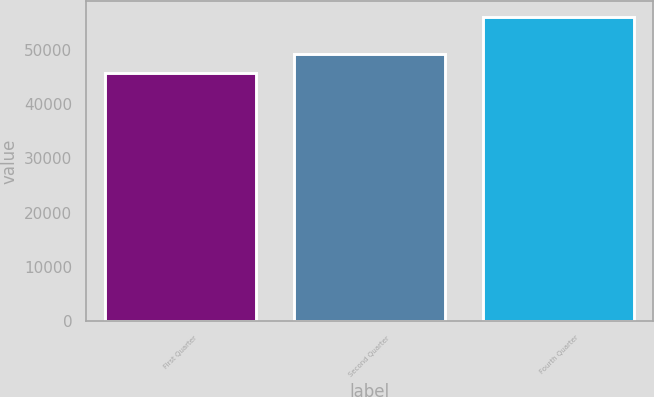Convert chart. <chart><loc_0><loc_0><loc_500><loc_500><bar_chart><fcel>First Quarter<fcel>Second Quarter<fcel>Fourth Quarter<nl><fcel>45670<fcel>49310<fcel>56101<nl></chart> 